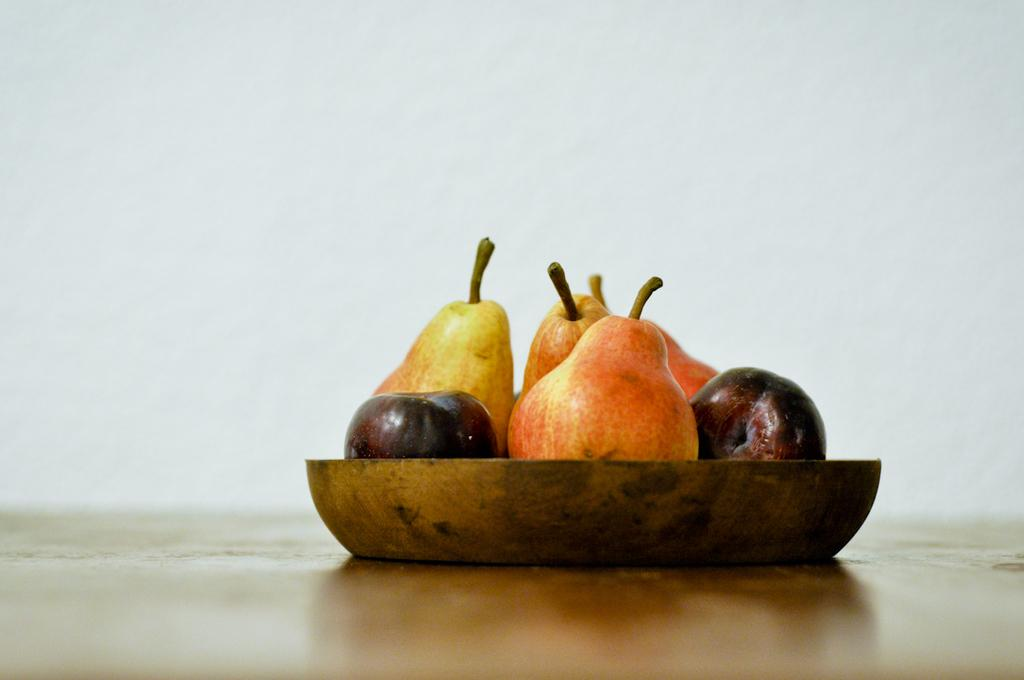What is in the bowl that is visible in the image? There are fruits in a bowl in the image. Where is the bowl located in the image? The bowl is on a surface in the image. What can be seen in the background of the image? There is a white color wall in the background of the image. What type of glove can be seen on the fruits in the image? There is no glove present on the fruits in the image. How does the distribution of fruits in the bowl affect the overall composition of the image? The distribution of fruits in the bowl does not affect the overall composition of the image, as the image only shows the bowl of fruits on a surface with a white color wall in the background. 